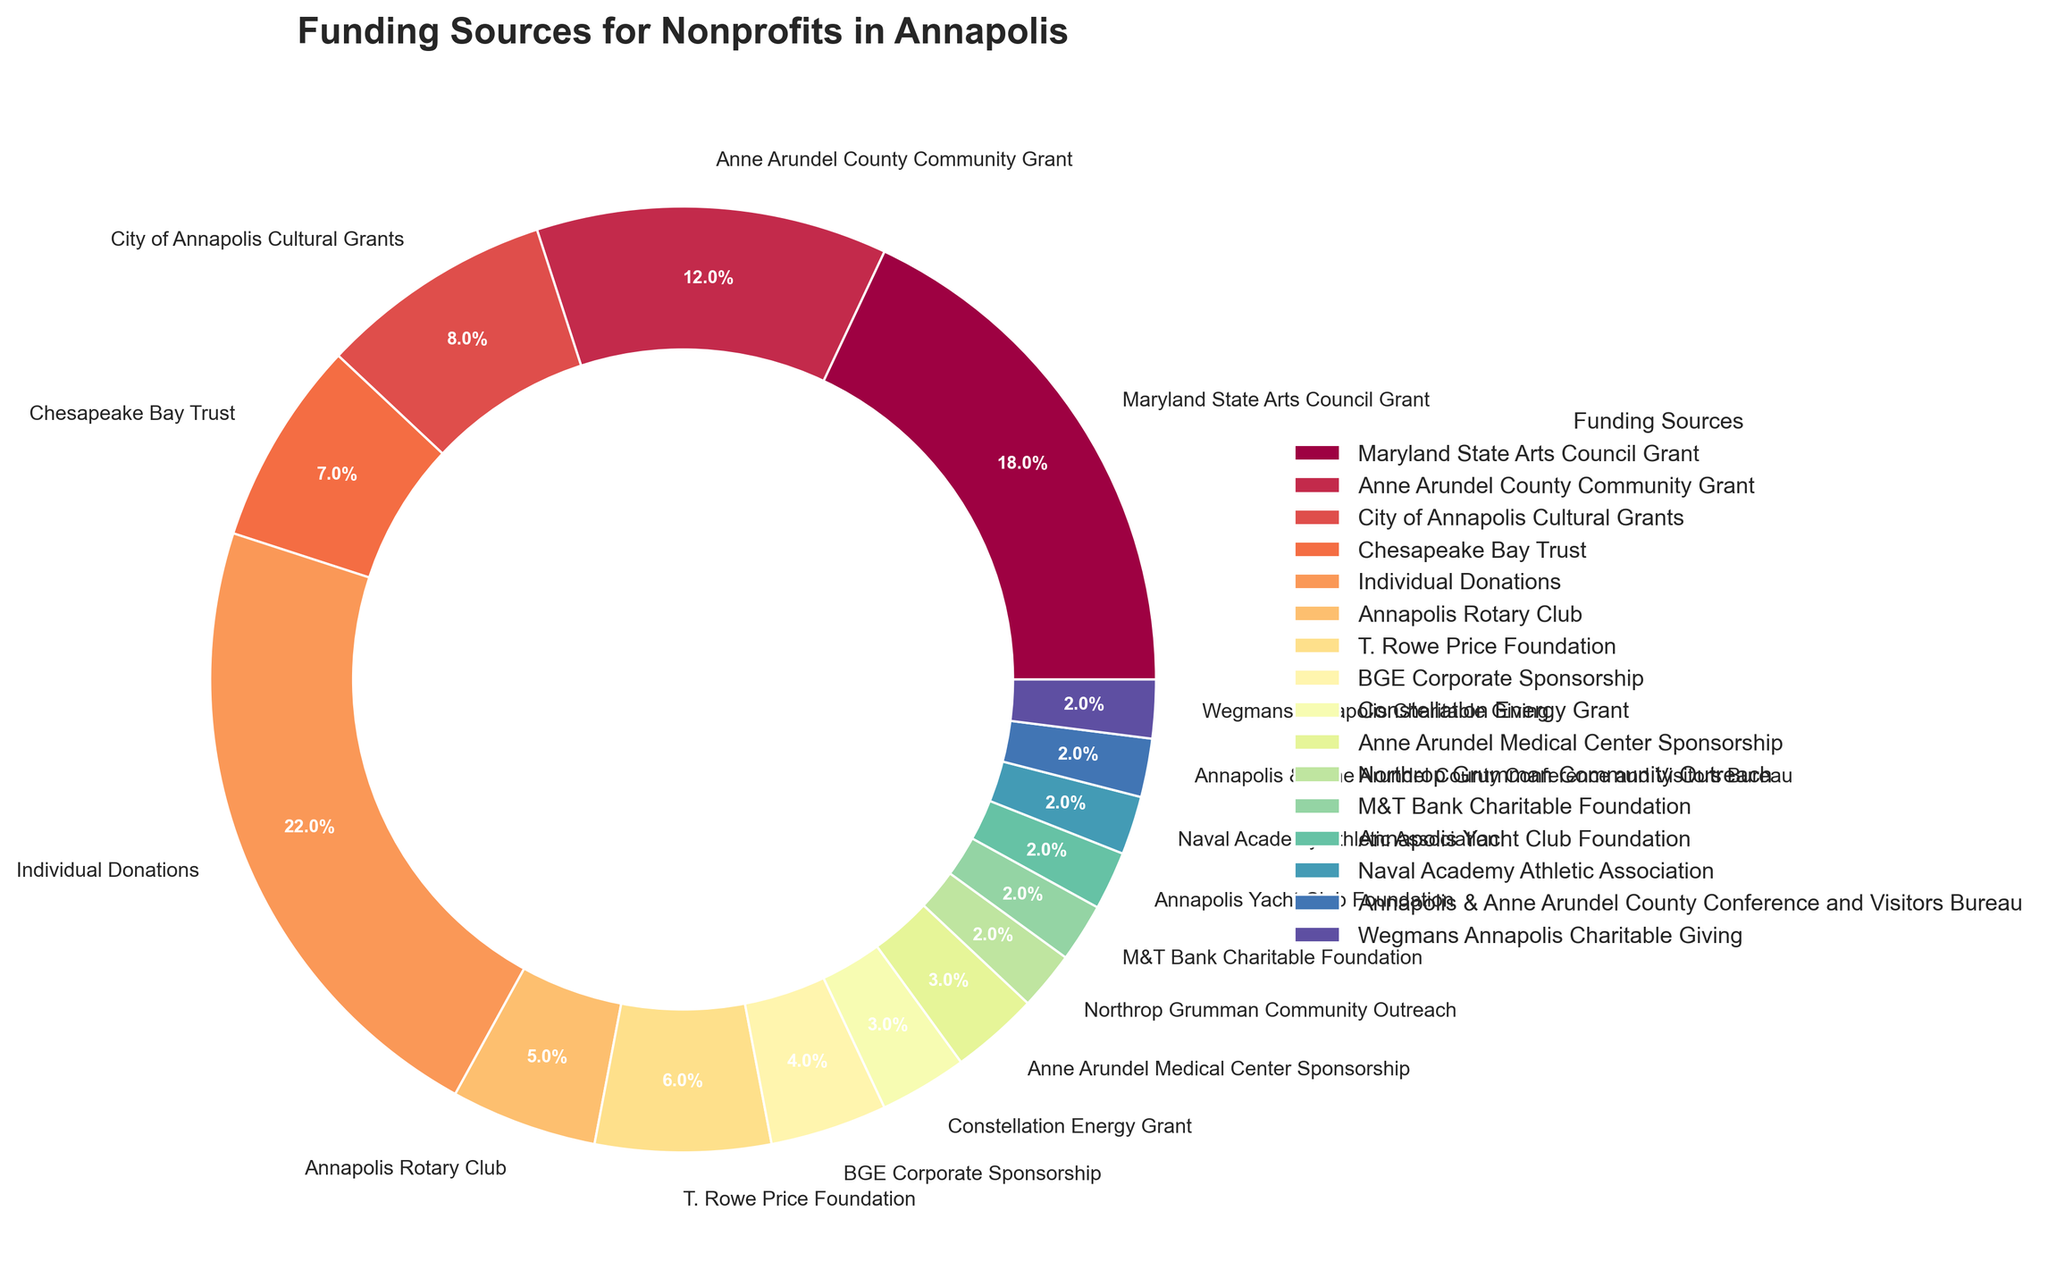Which funding source contributes the highest percentage? Look at the pie chart and identify the segment with the largest percentage label. The largest slice, representing 22%, corresponds to Individual Donations.
Answer: Individual Donations What is the combined percentage of the top three funding sources? Identify the top three segments by highest percentages: Individual Donations (22%), Maryland State Arts Council Grant (18%), and Anne Arundel County Community Grant (12%). Add them together: 22 + 18 + 12 = 52%.
Answer: 52% Which funding source has a larger percentage: Chesapeake Bay Trust or City of Annapolis Cultural Grants? Compare the percentage labels of Chesapeake Bay Trust (7%) and City of Annapolis Cultural Grants (8%). Since 8% is larger than 7%, City of Annapolis Cultural Grants has a larger percentage.
Answer: City of Annapolis Cultural Grants How many funding sources contribute 2% each? Look at the pie chart and identify all segments labeled with 2%. There are six segments: Northrop Grumman Community Outreach, M&T Bank Charitable Foundation, Annapolis Yacht Club Foundation, Naval Academy Athletic Association, Annapolis & Anne Arundel County Conference and Visitors Bureau, Wegmans Annapolis Charitable Giving. Count these segments.
Answer: 6 What is the combined contribution of all corporate sponsorships (BGE Corporate Sponsorship, Constellation Energy Grant, Anne Arundel Medical Center Sponsorship)? Identify the segments labeled BGE Corporate Sponsorship (4%), Constellation Energy Grant (3%), and Anne Arundel Medical Center Sponsorship (3%). Add them together: 4 + 3 + 3 = 10%.
Answer: 10% Which funding source has a similar percentage contribution to T. Rowe Price Foundation? Identify T. Rowe Price Foundation's percentage (6%) and look for another segment with a similar percentage. Chesapeake Bay Trust contributes 7%, close to 6%.
Answer: Chesapeake Bay Trust Is the sum of Annapolis Rotary Club and Maryland State Arts Council Grant less than or greater than the sum of BGE Corporate Sponsorship and Constellation Energy Grant? Calculate the sums: Annapolis Rotary Club (5%) + Maryland State Arts Council Grant (18%) = 23%; BGE Corporate Sponsorship (4%) + Constellation Energy Grant (3%) = 7%. Since 23% > 7%, the sum of Annapolis Rotary Club and Maryland State Arts Council Grant is greater.
Answer: Greater What is the average percentage contribution of all funding sources contributing 5% or more? Identify sources with 5% or more: Individual Donations (22%), Maryland State Arts Council Grant (18%), Anne Arundel County Community Grant (12%), T. Rowe Price Foundation (6%), Chesapeake Bay Trust (7%), and Annapolis Rotary Club (5%). Calculate their average: (22 + 18 + 12 + 6 + 7 + 5) / 6 = 70 / 6 ≈ 11.67%.
Answer: ~11.67% Which funding source's segment has the widest section visually on the pie chart besides Individual Donations? Exclude Individual Donations (22%) and identify the next widest segment by visual inspection. Maryland State Arts Council Grant, labeled 18%, has the next widest section.
Answer: Maryland State Arts Council Grant If you were to merge the Annapolis & Anne Arundel County Conference and Visitors Bureau and Naval Academy Athletic Association contributions, what would their combined percentage be? Identify the percentages of Annapolis & Anne Arundel County Conference and Visitors Bureau (2%) and Naval Academy Athletic Association (2%). Add them together: 2 + 2 = 4%.
Answer: 4% 